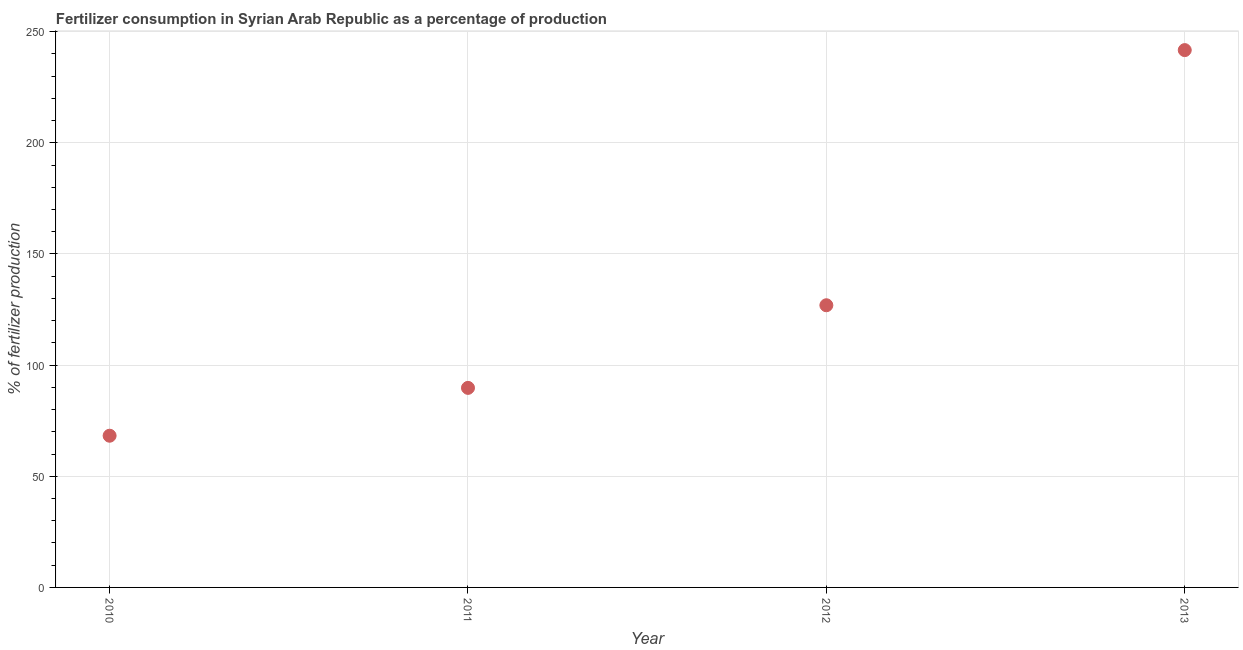What is the amount of fertilizer consumption in 2011?
Provide a succinct answer. 89.76. Across all years, what is the maximum amount of fertilizer consumption?
Your answer should be very brief. 241.69. Across all years, what is the minimum amount of fertilizer consumption?
Ensure brevity in your answer.  68.24. In which year was the amount of fertilizer consumption minimum?
Your answer should be very brief. 2010. What is the sum of the amount of fertilizer consumption?
Give a very brief answer. 526.61. What is the difference between the amount of fertilizer consumption in 2010 and 2013?
Offer a terse response. -173.45. What is the average amount of fertilizer consumption per year?
Offer a terse response. 131.65. What is the median amount of fertilizer consumption?
Offer a very short reply. 108.34. Do a majority of the years between 2013 and 2010 (inclusive) have amount of fertilizer consumption greater than 160 %?
Make the answer very short. Yes. What is the ratio of the amount of fertilizer consumption in 2010 to that in 2012?
Offer a very short reply. 0.54. Is the amount of fertilizer consumption in 2011 less than that in 2013?
Offer a very short reply. Yes. What is the difference between the highest and the second highest amount of fertilizer consumption?
Offer a very short reply. 114.77. What is the difference between the highest and the lowest amount of fertilizer consumption?
Give a very brief answer. 173.45. In how many years, is the amount of fertilizer consumption greater than the average amount of fertilizer consumption taken over all years?
Keep it short and to the point. 1. How many years are there in the graph?
Give a very brief answer. 4. Does the graph contain any zero values?
Offer a very short reply. No. Does the graph contain grids?
Your answer should be very brief. Yes. What is the title of the graph?
Offer a terse response. Fertilizer consumption in Syrian Arab Republic as a percentage of production. What is the label or title of the X-axis?
Offer a very short reply. Year. What is the label or title of the Y-axis?
Keep it short and to the point. % of fertilizer production. What is the % of fertilizer production in 2010?
Make the answer very short. 68.24. What is the % of fertilizer production in 2011?
Ensure brevity in your answer.  89.76. What is the % of fertilizer production in 2012?
Keep it short and to the point. 126.92. What is the % of fertilizer production in 2013?
Your answer should be compact. 241.69. What is the difference between the % of fertilizer production in 2010 and 2011?
Offer a very short reply. -21.52. What is the difference between the % of fertilizer production in 2010 and 2012?
Give a very brief answer. -58.69. What is the difference between the % of fertilizer production in 2010 and 2013?
Provide a short and direct response. -173.45. What is the difference between the % of fertilizer production in 2011 and 2012?
Your response must be concise. -37.17. What is the difference between the % of fertilizer production in 2011 and 2013?
Ensure brevity in your answer.  -151.93. What is the difference between the % of fertilizer production in 2012 and 2013?
Your response must be concise. -114.77. What is the ratio of the % of fertilizer production in 2010 to that in 2011?
Keep it short and to the point. 0.76. What is the ratio of the % of fertilizer production in 2010 to that in 2012?
Ensure brevity in your answer.  0.54. What is the ratio of the % of fertilizer production in 2010 to that in 2013?
Offer a very short reply. 0.28. What is the ratio of the % of fertilizer production in 2011 to that in 2012?
Provide a succinct answer. 0.71. What is the ratio of the % of fertilizer production in 2011 to that in 2013?
Make the answer very short. 0.37. What is the ratio of the % of fertilizer production in 2012 to that in 2013?
Provide a succinct answer. 0.53. 